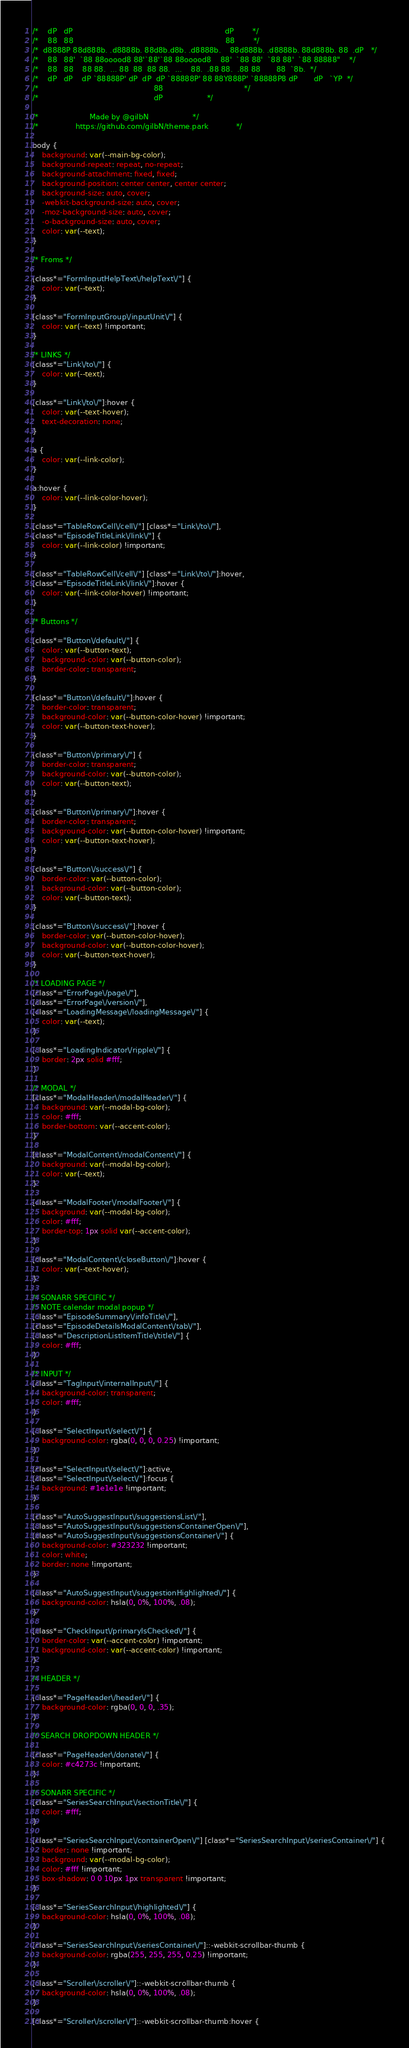Convert code to text. <code><loc_0><loc_0><loc_500><loc_500><_CSS_>/*    dP   dP                                                                  dP        */
/*    88   88                                                                  88        */
/*  d8888P 88d888b. .d8888b. 88d8b.d8b. .d8888b.    88d888b. .d8888b. 88d888b. 88  .dP   */
/*    88   88'  `88 88ooood8 88'`88'`88 88ooood8    88'  `88 88'  `88 88'  `88 88888"    */
/*    88   88    88 88.  ... 88  88  88 88.  ...    88.  .88 88.  .88 88       88  `8b.  */
/*    dP   dP    dP `88888P' dP  dP  dP `88888P' 88 88Y888P' `88888P8 dP       dP   `YP  */
/*                                                  88                                   */
/*                                                  dP					 */

/*		   		        Made by @gilbN					 */
/* 			      https://github.com/gilbN/theme.park			 */

body {
    background: var(--main-bg-color);
    background-repeat: repeat, no-repeat;
    background-attachment: fixed, fixed;
    background-position: center center, center center;
    background-size: auto, cover;
    -webkit-background-size: auto, cover;
    -moz-background-size: auto, cover;
    -o-background-size: auto, cover;
    color: var(--text);
}

/* Froms */

[class*="FormInputHelpText\/helpText\/"] {
    color: var(--text);
}

[class*="FormInputGroup\/inputUnit\/"] {
    color: var(--text) !important;
}

/* LINKS */
[class*="Link\/to\/"] {
    color: var(--text);
}

[class*="Link\/to\/"]:hover {
    color: var(--text-hover);
    text-decoration: none;
}

a {
    color: var(--link-color);
}

a:hover {
    color: var(--link-color-hover);
}

[class*="TableRowCell\/cell\/"] [class*="Link\/to\/"],
[class*="EpisodeTitleLink\/link\/"] {
    color: var(--link-color) !important;
}

[class*="TableRowCell\/cell\/"] [class*="Link\/to\/"]:hover,
[class*="EpisodeTitleLink\/link\/"]:hover {
    color: var(--link-color-hover) !important;
}

/* Buttons */

[class*="Button\/default\/"] {
    color: var(--button-text);
    background-color: var(--button-color);
    border-color: transparent;
}

[class*="Button\/default\/"]:hover {
    border-color: transparent;
    background-color: var(--button-color-hover) !important;
    color: var(--button-text-hover);
}

[class*="Button\/primary\/"] {
    border-color: transparent;
    background-color: var(--button-color);
    color: var(--button-text);
}

[class*="Button\/primary\/"]:hover {
    border-color: transparent;
    background-color: var(--button-color-hover) !important;
    color: var(--button-text-hover);
}

[class*="Button\/success\/"] {
    border-color: var(--button-color);
    background-color: var(--button-color);
    color: var(--button-text);
}

[class*="Button\/success\/"]:hover {
    border-color: var(--button-color-hover);
    background-color: var(--button-color-hover);
    color: var(--button-text-hover);
}

/* LOADING PAGE */
[class*="ErrorPage\/page\/"],
[class*="ErrorPage\/version\/"],
[class*="LoadingMessage\/loadingMessage\/"] {
    color: var(--text);
}

[class*="LoadingIndicator\/ripple\/"] {
    border: 2px solid #fff;
}

/* MODAL */
[class*="ModalHeader\/modalHeader\/"] {
    background: var(--modal-bg-color);
    color: #fff;
    border-bottom: var(--accent-color);
}

[class*="ModalContent\/modalContent\/"] {
    background: var(--modal-bg-color);
    color: var(--text);
}

[class*="ModalFooter\/modalFooter\/"] {
    background: var(--modal-bg-color);
    color: #fff;
    border-top: 1px solid var(--accent-color);
}

[class*="ModalContent\/closeButton\/"]:hover {
    color: var(--text-hover);
}

/* SONARR SPECIFIC */
/* NOTE calendar modal popup */
[class*="EpisodeSummary\/infoTitle\/"],
[class*="EpisodeDetailsModalContent\/tab\/"],
[class*="DescriptionListItemTitle\/title\/"] {
    color: #fff;
}

/* INPUT */
[class*="TagInput\/internalInput\/"] {
    background-color: transparent;
    color: #fff;
}

[class*="SelectInput\/select\/"] {
    background-color: rgba(0, 0, 0, 0.25) !important;
}

[class*="SelectInput\/select\/"]:active,
[class*="SelectInput\/select\/"]:focus {
    background: #1e1e1e !important;
}

[class*="AutoSuggestInput\/suggestionsList\/"],
[class*="AutoSuggestInput\/suggestionsContainerOpen\/"],
[class*="AutoSuggestInput\/suggestionsContainer\/"] {
    background-color: #323232 !important;
    color: white;
    border: none !important;
}

[class*="AutoSuggestInput\/suggestionHighlighted\/"] {
    background-color: hsla(0, 0%, 100%, .08);
}

[class*="CheckInput\/primaryIsChecked\/"] {
    border-color: var(--accent-color) !important;
    background-color: var(--accent-color) !important;
}

/* HEADER */

[class*="PageHeader\/header\/"] {
    background-color: rgba(0, 0, 0, .35);
}

/* SEARCH DROPDOWN HEADER */

[class*="PageHeader\/donate\/"] {
    color: #c4273c !important;
}

/* SONARR SPECIFIC */
[class*="SeriesSearchInput\/sectionTitle\/"] {
    color: #fff;
}

[class*="SeriesSearchInput\/containerOpen\/"] [class*="SeriesSearchInput\/seriesContainer\/"] {
    border: none !important;
    background: var(--modal-bg-color);
    color: #fff !important;
    box-shadow: 0 0 10px 1px transparent !important;
}

[class*="SeriesSearchInput\/highlighted\/"] {
    background-color: hsla(0, 0%, 100%, .08);
}

[class*="SeriesSearchInput\/seriesContainer\/"]::-webkit-scrollbar-thumb {
    background-color: rgba(255, 255, 255, 0.25) !important;
}

[class*="Scroller\/scroller\/"]::-webkit-scrollbar-thumb {
    background-color: hsla(0, 0%, 100%, .08);
}

[class*="Scroller\/scroller\/"]::-webkit-scrollbar-thumb:hover {</code> 